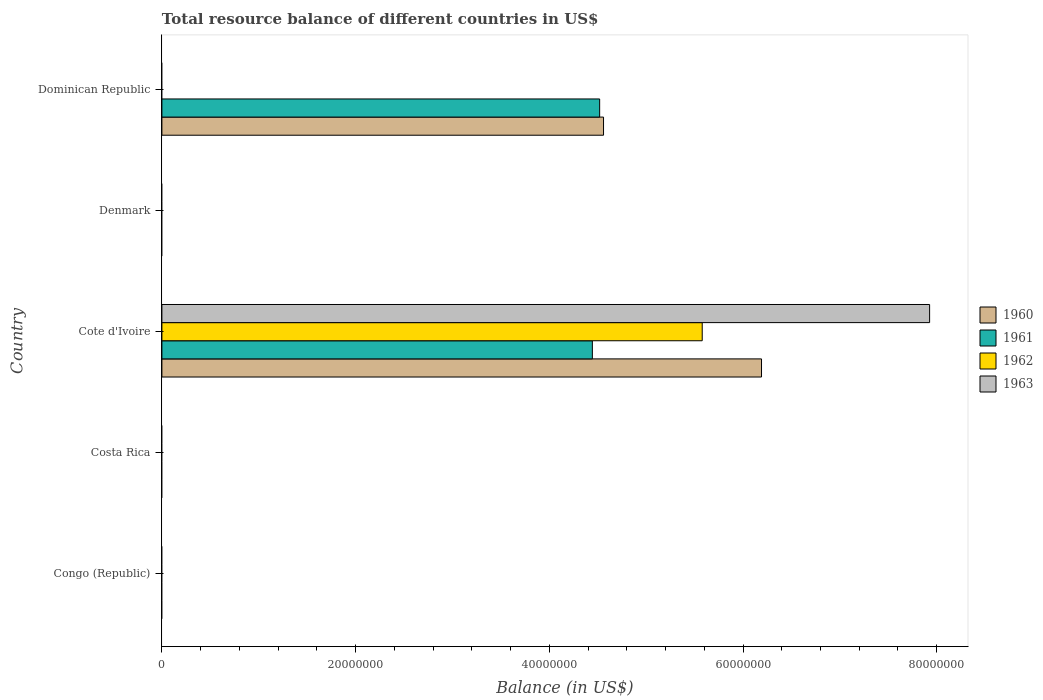How many different coloured bars are there?
Ensure brevity in your answer.  4. Are the number of bars on each tick of the Y-axis equal?
Your response must be concise. No. How many bars are there on the 3rd tick from the top?
Ensure brevity in your answer.  4. How many bars are there on the 1st tick from the bottom?
Provide a succinct answer. 0. What is the label of the 3rd group of bars from the top?
Offer a very short reply. Cote d'Ivoire. What is the total resource balance in 1962 in Cote d'Ivoire?
Your response must be concise. 5.58e+07. Across all countries, what is the maximum total resource balance in 1962?
Offer a terse response. 5.58e+07. Across all countries, what is the minimum total resource balance in 1961?
Your answer should be very brief. 0. In which country was the total resource balance in 1963 maximum?
Give a very brief answer. Cote d'Ivoire. What is the total total resource balance in 1960 in the graph?
Your answer should be very brief. 1.08e+08. What is the difference between the total resource balance in 1962 in Congo (Republic) and the total resource balance in 1961 in Cote d'Ivoire?
Provide a short and direct response. -4.44e+07. What is the average total resource balance in 1961 per country?
Give a very brief answer. 1.79e+07. In how many countries, is the total resource balance in 1963 greater than 76000000 US$?
Keep it short and to the point. 1. What is the difference between the highest and the lowest total resource balance in 1963?
Make the answer very short. 7.93e+07. In how many countries, is the total resource balance in 1963 greater than the average total resource balance in 1963 taken over all countries?
Provide a short and direct response. 1. Is it the case that in every country, the sum of the total resource balance in 1960 and total resource balance in 1963 is greater than the sum of total resource balance in 1962 and total resource balance in 1961?
Keep it short and to the point. No. Is it the case that in every country, the sum of the total resource balance in 1963 and total resource balance in 1960 is greater than the total resource balance in 1961?
Your answer should be very brief. No. How many bars are there?
Offer a terse response. 6. What is the difference between two consecutive major ticks on the X-axis?
Ensure brevity in your answer.  2.00e+07. Does the graph contain any zero values?
Your response must be concise. Yes. Does the graph contain grids?
Offer a terse response. No. How many legend labels are there?
Make the answer very short. 4. What is the title of the graph?
Provide a short and direct response. Total resource balance of different countries in US$. Does "1961" appear as one of the legend labels in the graph?
Provide a short and direct response. Yes. What is the label or title of the X-axis?
Make the answer very short. Balance (in US$). What is the Balance (in US$) in 1960 in Congo (Republic)?
Give a very brief answer. 0. What is the Balance (in US$) in 1961 in Congo (Republic)?
Give a very brief answer. 0. What is the Balance (in US$) of 1962 in Congo (Republic)?
Keep it short and to the point. 0. What is the Balance (in US$) in 1963 in Congo (Republic)?
Offer a terse response. 0. What is the Balance (in US$) of 1960 in Costa Rica?
Provide a succinct answer. 0. What is the Balance (in US$) of 1961 in Costa Rica?
Make the answer very short. 0. What is the Balance (in US$) in 1962 in Costa Rica?
Your answer should be very brief. 0. What is the Balance (in US$) of 1963 in Costa Rica?
Offer a terse response. 0. What is the Balance (in US$) in 1960 in Cote d'Ivoire?
Your answer should be compact. 6.19e+07. What is the Balance (in US$) in 1961 in Cote d'Ivoire?
Make the answer very short. 4.44e+07. What is the Balance (in US$) of 1962 in Cote d'Ivoire?
Keep it short and to the point. 5.58e+07. What is the Balance (in US$) of 1963 in Cote d'Ivoire?
Keep it short and to the point. 7.93e+07. What is the Balance (in US$) in 1962 in Denmark?
Offer a very short reply. 0. What is the Balance (in US$) in 1960 in Dominican Republic?
Ensure brevity in your answer.  4.56e+07. What is the Balance (in US$) in 1961 in Dominican Republic?
Provide a short and direct response. 4.52e+07. Across all countries, what is the maximum Balance (in US$) in 1960?
Your response must be concise. 6.19e+07. Across all countries, what is the maximum Balance (in US$) in 1961?
Provide a short and direct response. 4.52e+07. Across all countries, what is the maximum Balance (in US$) in 1962?
Provide a short and direct response. 5.58e+07. Across all countries, what is the maximum Balance (in US$) in 1963?
Keep it short and to the point. 7.93e+07. Across all countries, what is the minimum Balance (in US$) in 1961?
Your answer should be compact. 0. Across all countries, what is the minimum Balance (in US$) in 1962?
Your response must be concise. 0. Across all countries, what is the minimum Balance (in US$) of 1963?
Offer a very short reply. 0. What is the total Balance (in US$) in 1960 in the graph?
Provide a succinct answer. 1.08e+08. What is the total Balance (in US$) of 1961 in the graph?
Keep it short and to the point. 8.96e+07. What is the total Balance (in US$) of 1962 in the graph?
Offer a terse response. 5.58e+07. What is the total Balance (in US$) in 1963 in the graph?
Provide a short and direct response. 7.93e+07. What is the difference between the Balance (in US$) in 1960 in Cote d'Ivoire and that in Dominican Republic?
Provide a short and direct response. 1.63e+07. What is the difference between the Balance (in US$) of 1961 in Cote d'Ivoire and that in Dominican Republic?
Make the answer very short. -7.54e+05. What is the difference between the Balance (in US$) of 1960 in Cote d'Ivoire and the Balance (in US$) of 1961 in Dominican Republic?
Your response must be concise. 1.67e+07. What is the average Balance (in US$) in 1960 per country?
Keep it short and to the point. 2.15e+07. What is the average Balance (in US$) in 1961 per country?
Offer a very short reply. 1.79e+07. What is the average Balance (in US$) of 1962 per country?
Your answer should be very brief. 1.12e+07. What is the average Balance (in US$) of 1963 per country?
Make the answer very short. 1.59e+07. What is the difference between the Balance (in US$) of 1960 and Balance (in US$) of 1961 in Cote d'Ivoire?
Provide a succinct answer. 1.75e+07. What is the difference between the Balance (in US$) of 1960 and Balance (in US$) of 1962 in Cote d'Ivoire?
Your answer should be very brief. 6.12e+06. What is the difference between the Balance (in US$) of 1960 and Balance (in US$) of 1963 in Cote d'Ivoire?
Your answer should be compact. -1.74e+07. What is the difference between the Balance (in US$) of 1961 and Balance (in US$) of 1962 in Cote d'Ivoire?
Offer a very short reply. -1.13e+07. What is the difference between the Balance (in US$) in 1961 and Balance (in US$) in 1963 in Cote d'Ivoire?
Your answer should be very brief. -3.48e+07. What is the difference between the Balance (in US$) in 1962 and Balance (in US$) in 1963 in Cote d'Ivoire?
Your answer should be compact. -2.35e+07. What is the ratio of the Balance (in US$) of 1960 in Cote d'Ivoire to that in Dominican Republic?
Ensure brevity in your answer.  1.36. What is the ratio of the Balance (in US$) of 1961 in Cote d'Ivoire to that in Dominican Republic?
Offer a very short reply. 0.98. What is the difference between the highest and the lowest Balance (in US$) of 1960?
Your response must be concise. 6.19e+07. What is the difference between the highest and the lowest Balance (in US$) of 1961?
Give a very brief answer. 4.52e+07. What is the difference between the highest and the lowest Balance (in US$) of 1962?
Provide a short and direct response. 5.58e+07. What is the difference between the highest and the lowest Balance (in US$) of 1963?
Keep it short and to the point. 7.93e+07. 